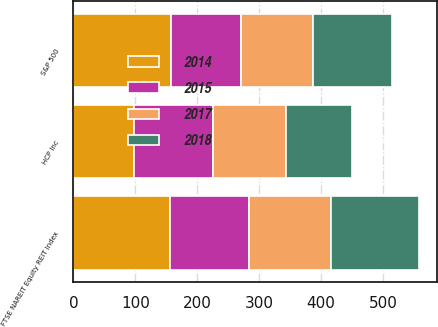Convert chart. <chart><loc_0><loc_0><loc_500><loc_500><stacked_bar_chart><ecel><fcel>FTSE NAREIT Equity REIT Index<fcel>S&P 500<fcel>HCP Inc<nl><fcel>2015<fcel>128.03<fcel>113.68<fcel>127.8<nl><fcel>2017<fcel>131.65<fcel>115.24<fcel>117.53<nl><fcel>2018<fcel>143.32<fcel>129.02<fcel>106.52<nl><fcel>2014<fcel>155.75<fcel>157.17<fcel>98.26<nl></chart> 